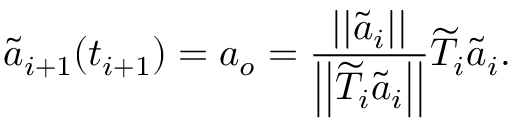Convert formula to latex. <formula><loc_0><loc_0><loc_500><loc_500>\widetilde { a } _ { i + 1 } ( t _ { i + 1 } ) = a _ { o } = \frac { | | \widetilde { a } _ { i } | | } { \left | \left | \widetilde { T } _ { i } \widetilde { a } _ { i } \right | \right | } \widetilde { T } _ { i } \widetilde { a } _ { i } .</formula> 